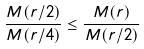Convert formula to latex. <formula><loc_0><loc_0><loc_500><loc_500>\frac { M ( r / 2 ) } { M ( r / 4 ) } \leq \frac { M ( r ) } { M ( r / 2 ) }</formula> 